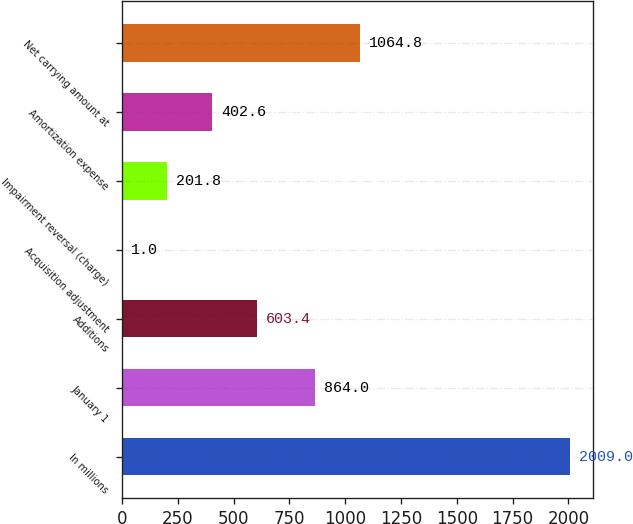Convert chart. <chart><loc_0><loc_0><loc_500><loc_500><bar_chart><fcel>In millions<fcel>January 1<fcel>Additions<fcel>Acquisition adjustment<fcel>Impairment reversal (charge)<fcel>Amortization expense<fcel>Net carrying amount at<nl><fcel>2009<fcel>864<fcel>603.4<fcel>1<fcel>201.8<fcel>402.6<fcel>1064.8<nl></chart> 